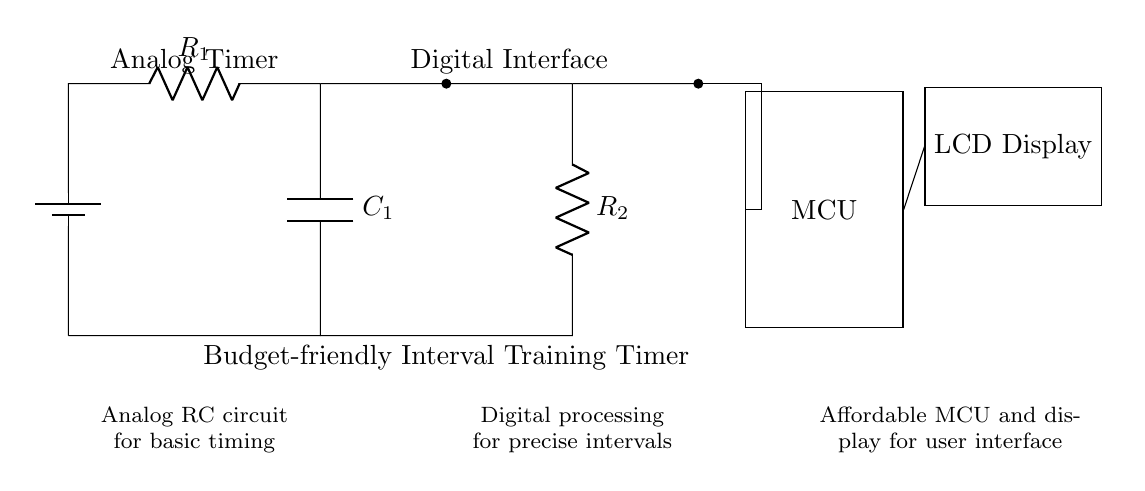What is the primary type of the timer in this circuit? The timer consists of an analog RC circuit which is designed for basic timing functions. The resistor and capacitor work together to establish a timing interval.
Answer: Analog RC What component provides the display functionality? The display functionality is provided by an LCD display connected to the microcontroller, allowing user interaction with the timer.
Answer: LCD Display How many resistors are present in the circuit? There are two resistors in the circuit: one in the analog section (R1) and another in the digital section (R2).
Answer: Two What role does the microcontroller play in this circuit? The microcontroller processes digital signals to calculate and manage precise timing intervals while serving as the central control unit of the circuit.
Answer: Digital processing Which part of the circuit is responsible for generating time intervals? The analog part, specifically the RC circuit (resistor and capacitor), is responsible for generating basic time intervals before being processed by the microcontroller for precise timing.
Answer: Analog Timer What is the purpose of the C1 component? The capacitor C1 is used in conjunction with R1 to form a timing circuit that helps set the time interval for the timer.
Answer: Timing How is the microcontroller connected to the rest of the circuit? The microcontroller is connected to both the digital interface and the LCD display, receiving and sending signals to manage the timer's functions.
Answer: Connections 